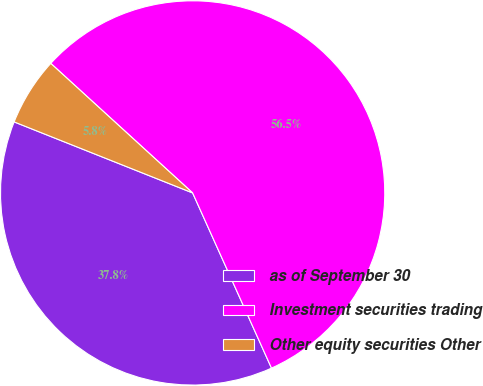<chart> <loc_0><loc_0><loc_500><loc_500><pie_chart><fcel>as of September 30<fcel>Investment securities trading<fcel>Other equity securities Other<nl><fcel>37.76%<fcel>56.49%<fcel>5.75%<nl></chart> 